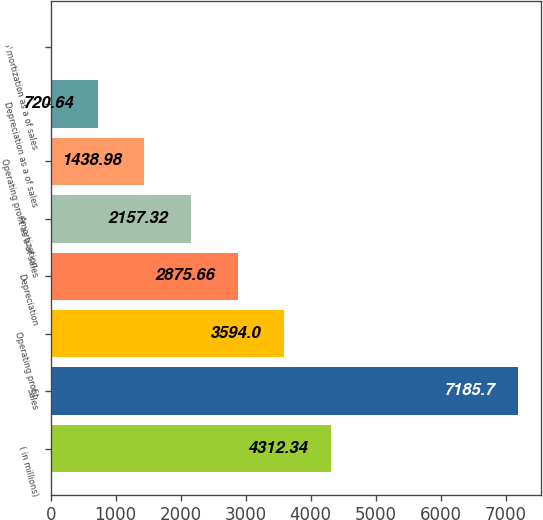<chart> <loc_0><loc_0><loc_500><loc_500><bar_chart><fcel>( in millions)<fcel>Sales<fcel>Operating profit<fcel>Depreciation<fcel>Amortization<fcel>Operating profit as a of sales<fcel>Depreciation as a of sales<fcel>Amortization as a of sales<nl><fcel>4312.34<fcel>7185.7<fcel>3594<fcel>2875.66<fcel>2157.32<fcel>1438.98<fcel>720.64<fcel>2.3<nl></chart> 